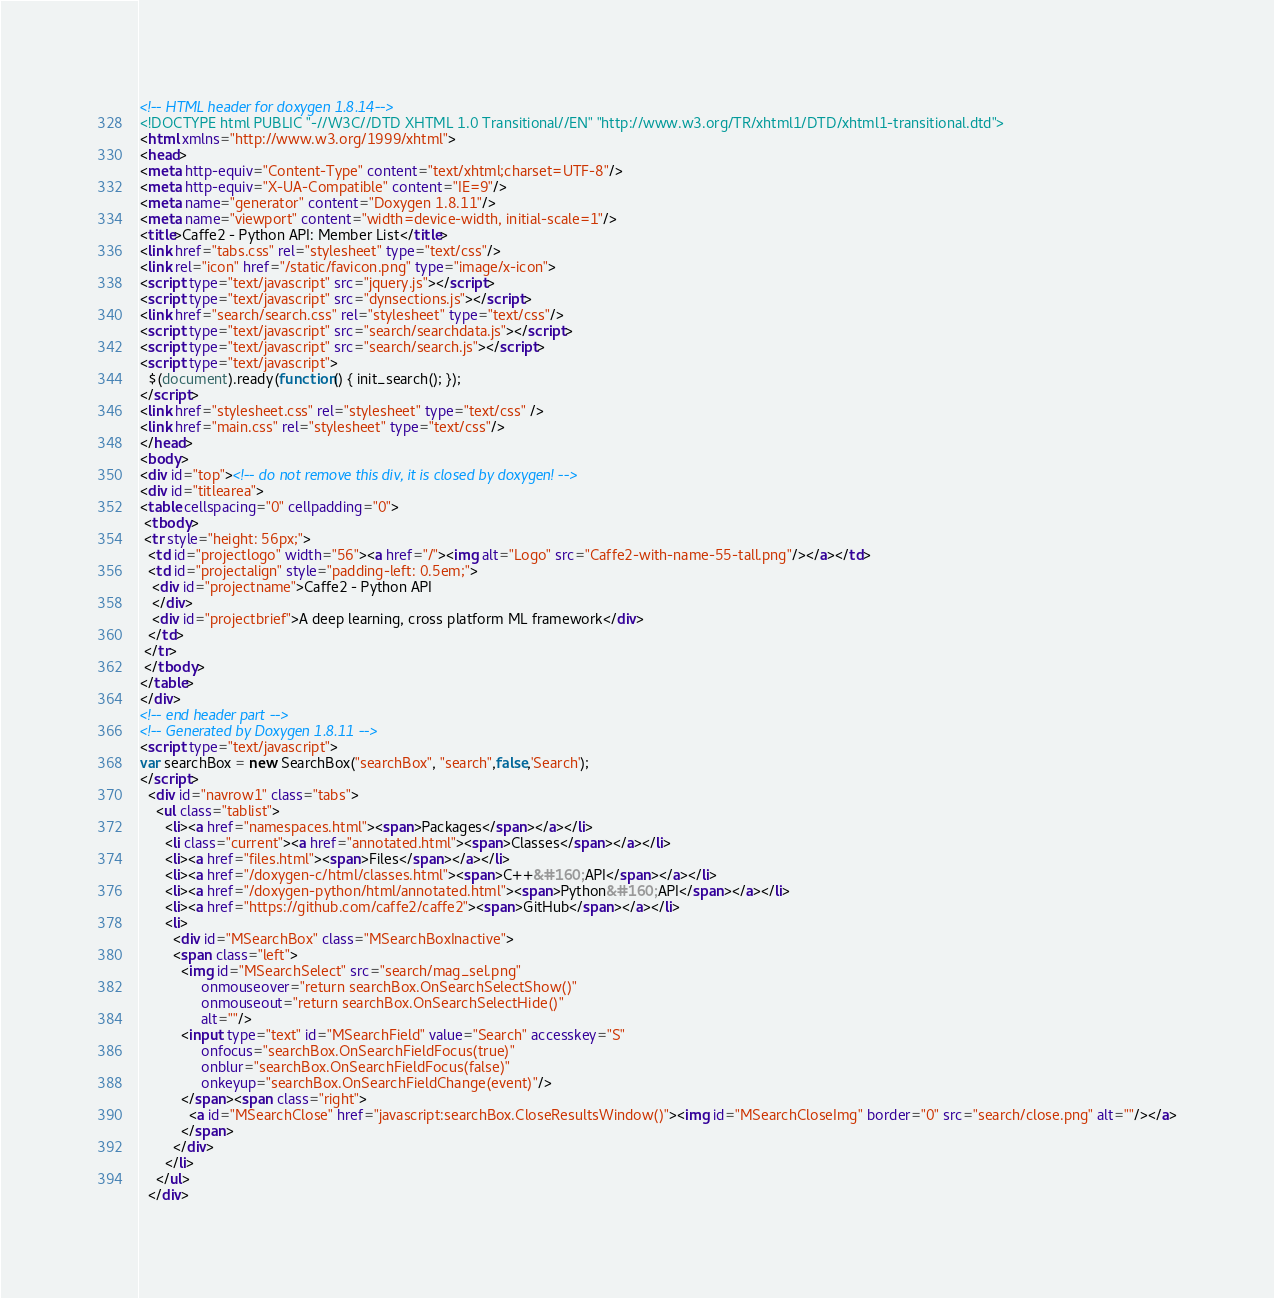Convert code to text. <code><loc_0><loc_0><loc_500><loc_500><_HTML_><!-- HTML header for doxygen 1.8.14-->
<!DOCTYPE html PUBLIC "-//W3C//DTD XHTML 1.0 Transitional//EN" "http://www.w3.org/TR/xhtml1/DTD/xhtml1-transitional.dtd">
<html xmlns="http://www.w3.org/1999/xhtml">
<head>
<meta http-equiv="Content-Type" content="text/xhtml;charset=UTF-8"/>
<meta http-equiv="X-UA-Compatible" content="IE=9"/>
<meta name="generator" content="Doxygen 1.8.11"/>
<meta name="viewport" content="width=device-width, initial-scale=1"/>
<title>Caffe2 - Python API: Member List</title>
<link href="tabs.css" rel="stylesheet" type="text/css"/>
<link rel="icon" href="/static/favicon.png" type="image/x-icon">
<script type="text/javascript" src="jquery.js"></script>
<script type="text/javascript" src="dynsections.js"></script>
<link href="search/search.css" rel="stylesheet" type="text/css"/>
<script type="text/javascript" src="search/searchdata.js"></script>
<script type="text/javascript" src="search/search.js"></script>
<script type="text/javascript">
  $(document).ready(function() { init_search(); });
</script>
<link href="stylesheet.css" rel="stylesheet" type="text/css" />
<link href="main.css" rel="stylesheet" type="text/css"/>
</head>
<body>
<div id="top"><!-- do not remove this div, it is closed by doxygen! -->
<div id="titlearea">
<table cellspacing="0" cellpadding="0">
 <tbody>
 <tr style="height: 56px;">
  <td id="projectlogo" width="56"><a href="/"><img alt="Logo" src="Caffe2-with-name-55-tall.png"/></a></td>
  <td id="projectalign" style="padding-left: 0.5em;">
   <div id="projectname">Caffe2 - Python API
   </div>
   <div id="projectbrief">A deep learning, cross platform ML framework</div>
  </td>
 </tr>
 </tbody>
</table>
</div>
<!-- end header part -->
<!-- Generated by Doxygen 1.8.11 -->
<script type="text/javascript">
var searchBox = new SearchBox("searchBox", "search",false,'Search');
</script>
  <div id="navrow1" class="tabs">
    <ul class="tablist">
      <li><a href="namespaces.html"><span>Packages</span></a></li>
      <li class="current"><a href="annotated.html"><span>Classes</span></a></li>
      <li><a href="files.html"><span>Files</span></a></li>
      <li><a href="/doxygen-c/html/classes.html"><span>C++&#160;API</span></a></li>
      <li><a href="/doxygen-python/html/annotated.html"><span>Python&#160;API</span></a></li>
      <li><a href="https://github.com/caffe2/caffe2"><span>GitHub</span></a></li>
      <li>
        <div id="MSearchBox" class="MSearchBoxInactive">
        <span class="left">
          <img id="MSearchSelect" src="search/mag_sel.png"
               onmouseover="return searchBox.OnSearchSelectShow()"
               onmouseout="return searchBox.OnSearchSelectHide()"
               alt=""/>
          <input type="text" id="MSearchField" value="Search" accesskey="S"
               onfocus="searchBox.OnSearchFieldFocus(true)" 
               onblur="searchBox.OnSearchFieldFocus(false)" 
               onkeyup="searchBox.OnSearchFieldChange(event)"/>
          </span><span class="right">
            <a id="MSearchClose" href="javascript:searchBox.CloseResultsWindow()"><img id="MSearchCloseImg" border="0" src="search/close.png" alt=""/></a>
          </span>
        </div>
      </li>
    </ul>
  </div></code> 